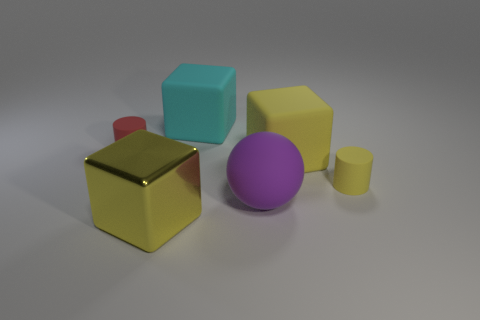What size is the matte cube that is the same color as the large metallic object?
Provide a short and direct response. Large. Is the color of the big matte cube that is in front of the big cyan matte object the same as the metal object?
Ensure brevity in your answer.  Yes. How many other things are there of the same color as the large metallic block?
Provide a succinct answer. 2. There is a tiny red cylinder; how many matte objects are in front of it?
Your response must be concise. 3. Are there any big yellow metallic objects that have the same shape as the cyan object?
Provide a succinct answer. Yes. There is a small yellow object; is its shape the same as the small rubber object on the left side of the purple rubber object?
Your response must be concise. Yes. How many blocks are large shiny objects or matte objects?
Give a very brief answer. 3. There is a big yellow thing on the right side of the purple matte object; what is its shape?
Offer a terse response. Cube. How many other purple balls have the same material as the purple ball?
Make the answer very short. 0. Is the number of things in front of the small red cylinder less than the number of objects?
Make the answer very short. Yes. 